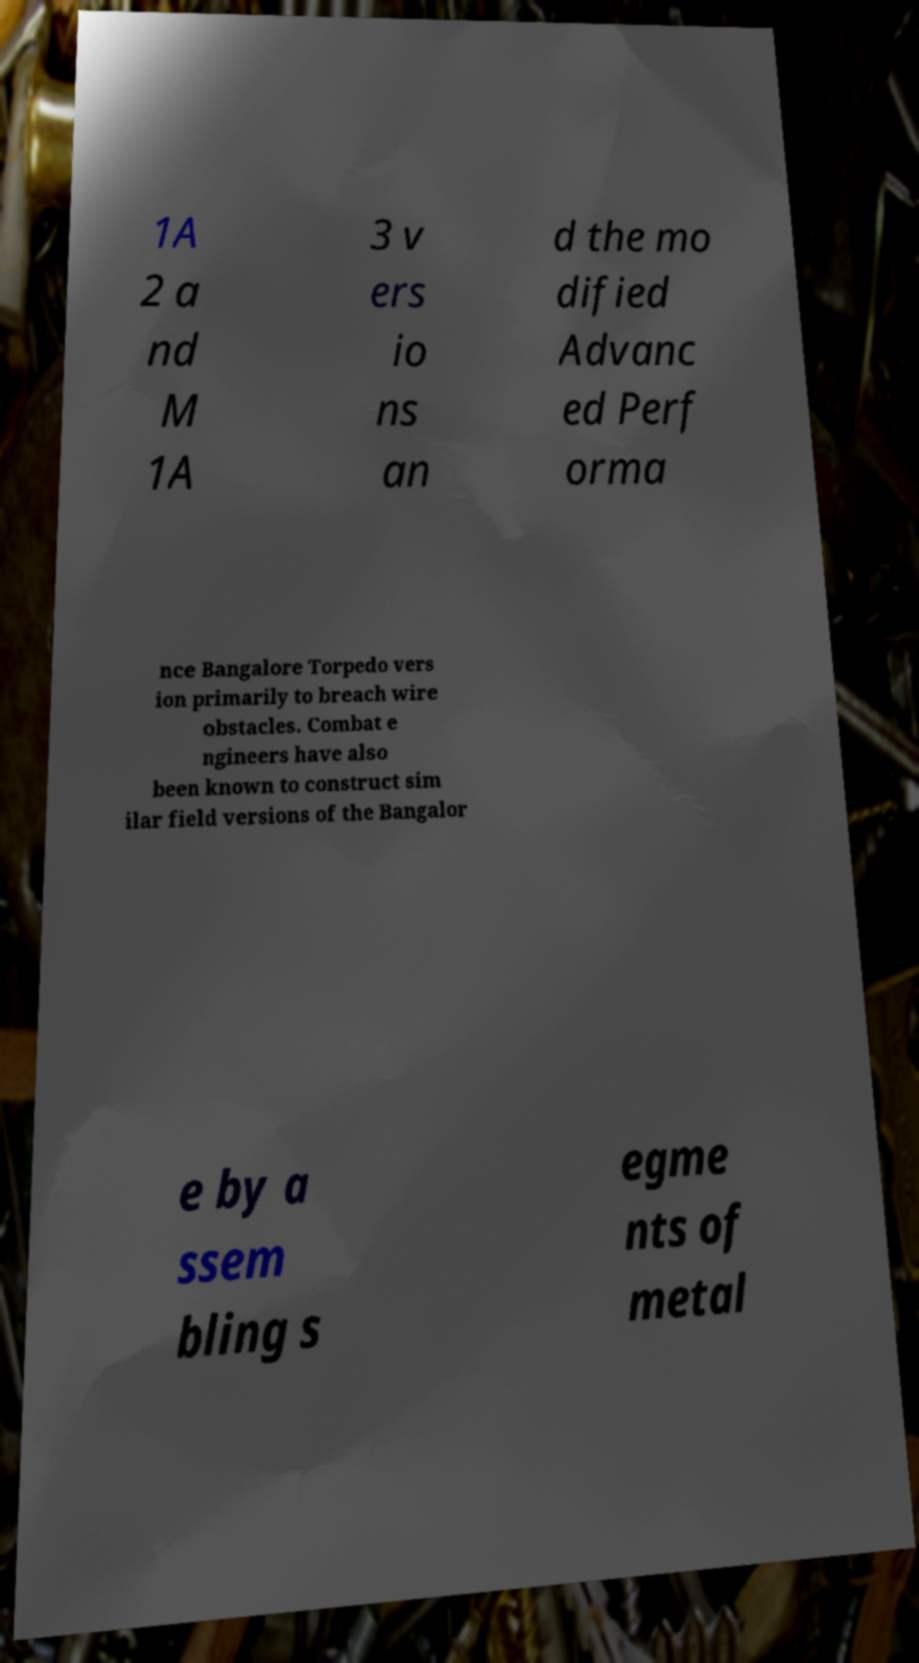Please identify and transcribe the text found in this image. 1A 2 a nd M 1A 3 v ers io ns an d the mo dified Advanc ed Perf orma nce Bangalore Torpedo vers ion primarily to breach wire obstacles. Combat e ngineers have also been known to construct sim ilar field versions of the Bangalor e by a ssem bling s egme nts of metal 